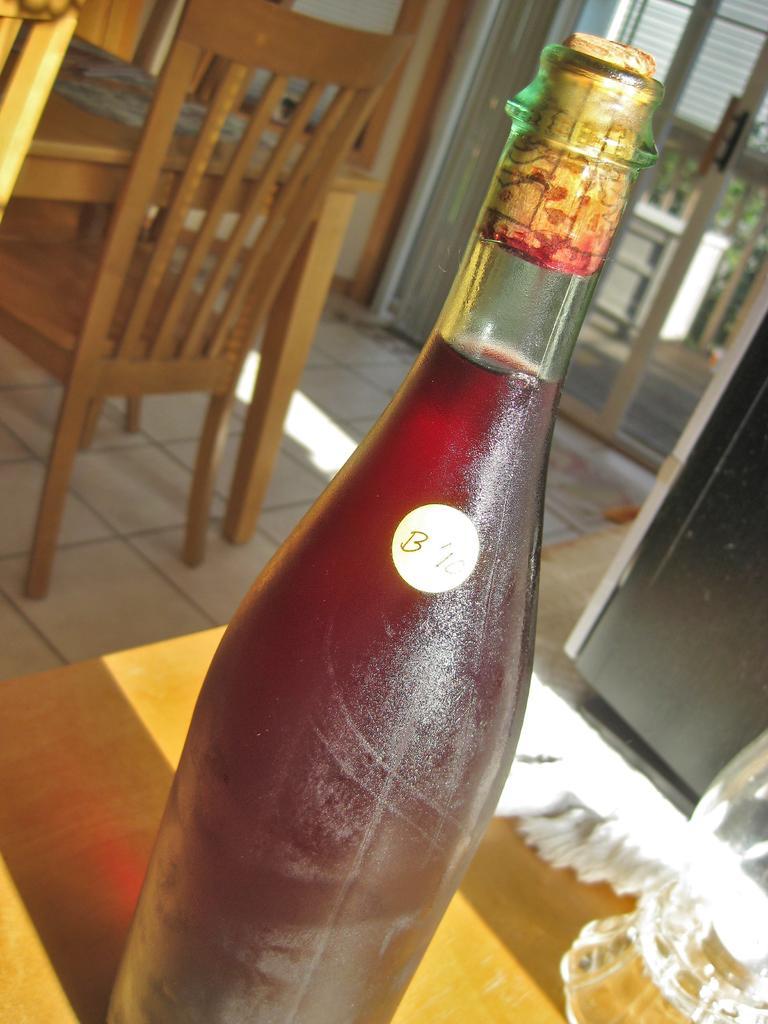Describe this image in one or two sentences. The picture is taken in a closed room where the bottle is present on the table and behind the bottle at the right corner there are chairs and tables and behind them there is a door and outside the door there is one table and trees. 